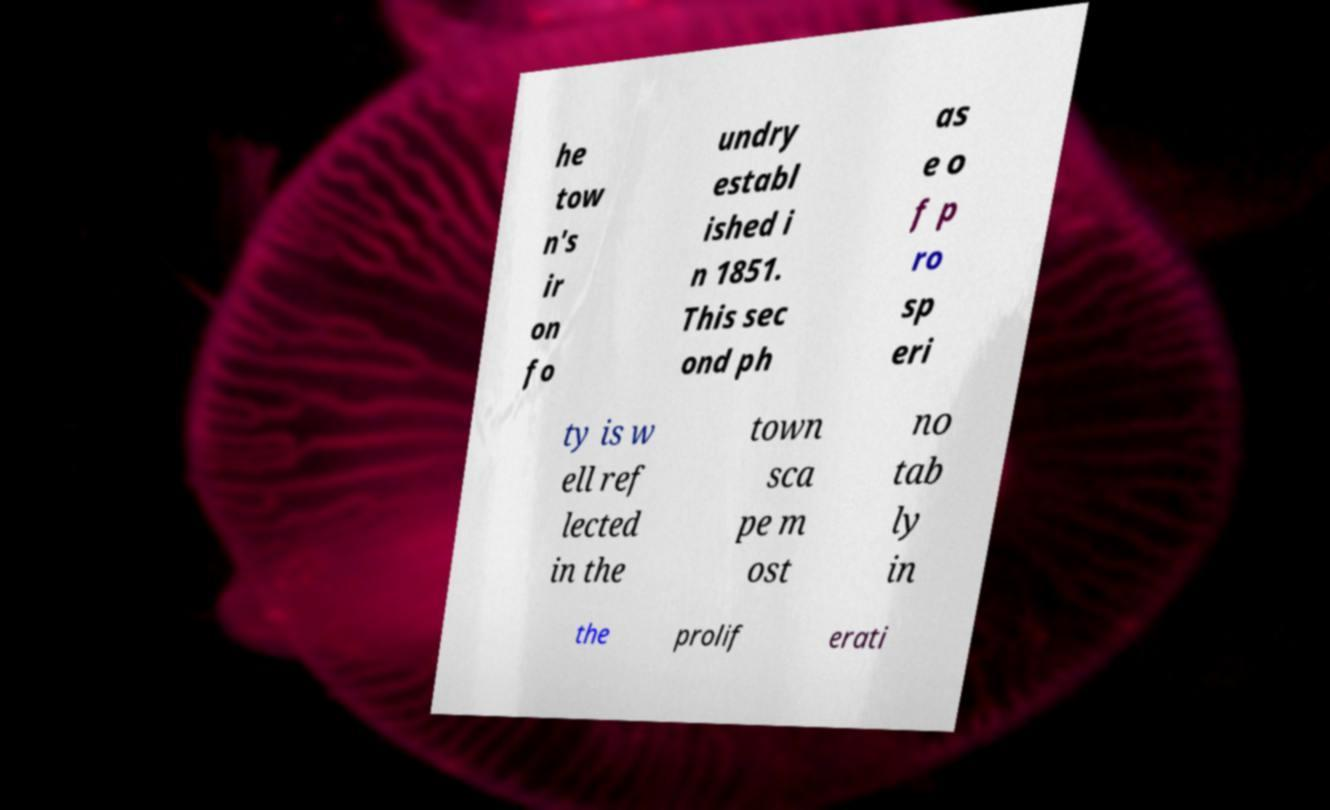What messages or text are displayed in this image? I need them in a readable, typed format. he tow n's ir on fo undry establ ished i n 1851. This sec ond ph as e o f p ro sp eri ty is w ell ref lected in the town sca pe m ost no tab ly in the prolif erati 